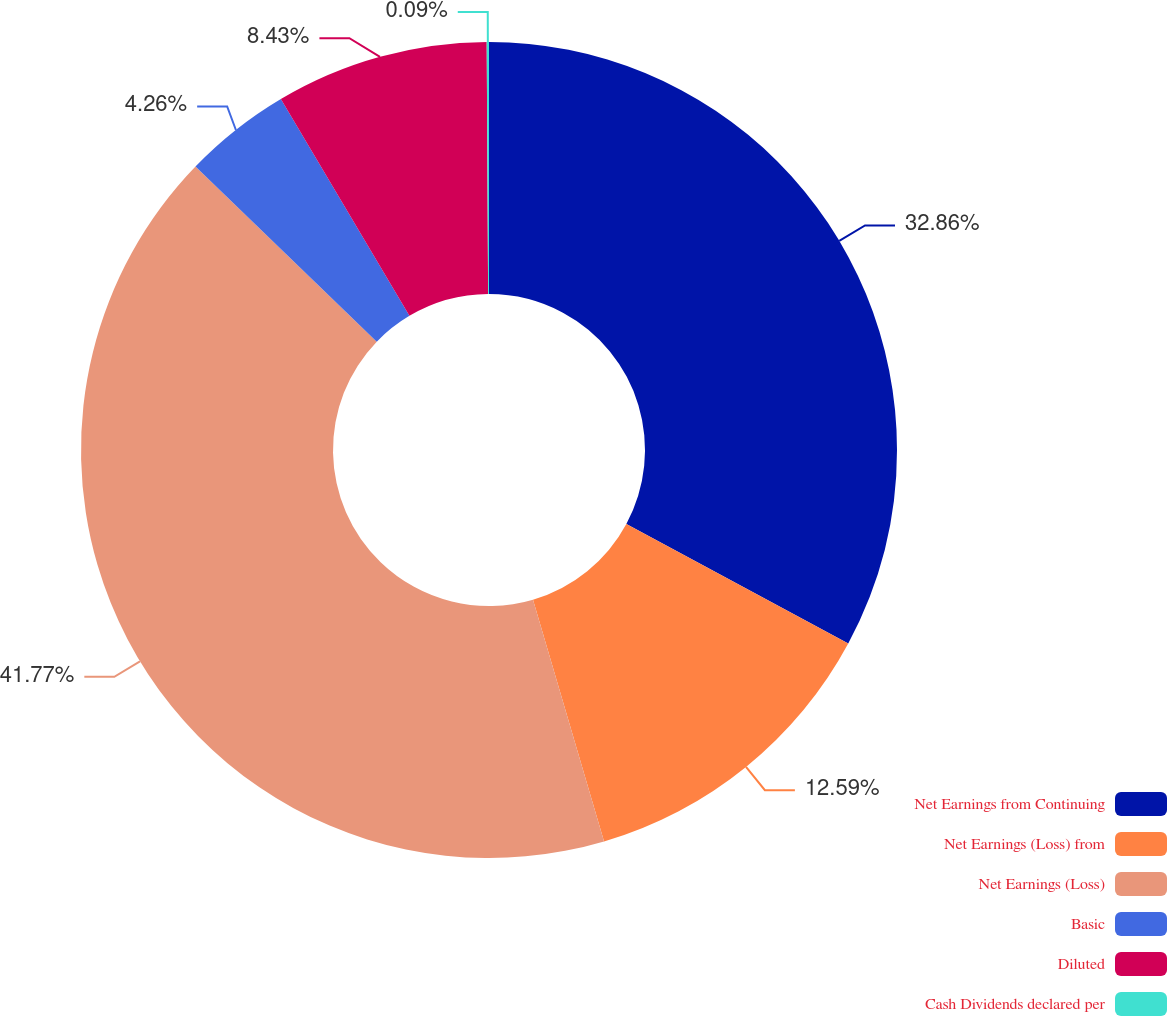Convert chart. <chart><loc_0><loc_0><loc_500><loc_500><pie_chart><fcel>Net Earnings from Continuing<fcel>Net Earnings (Loss) from<fcel>Net Earnings (Loss)<fcel>Basic<fcel>Diluted<fcel>Cash Dividends declared per<nl><fcel>32.86%<fcel>12.59%<fcel>41.77%<fcel>4.26%<fcel>8.43%<fcel>0.09%<nl></chart> 